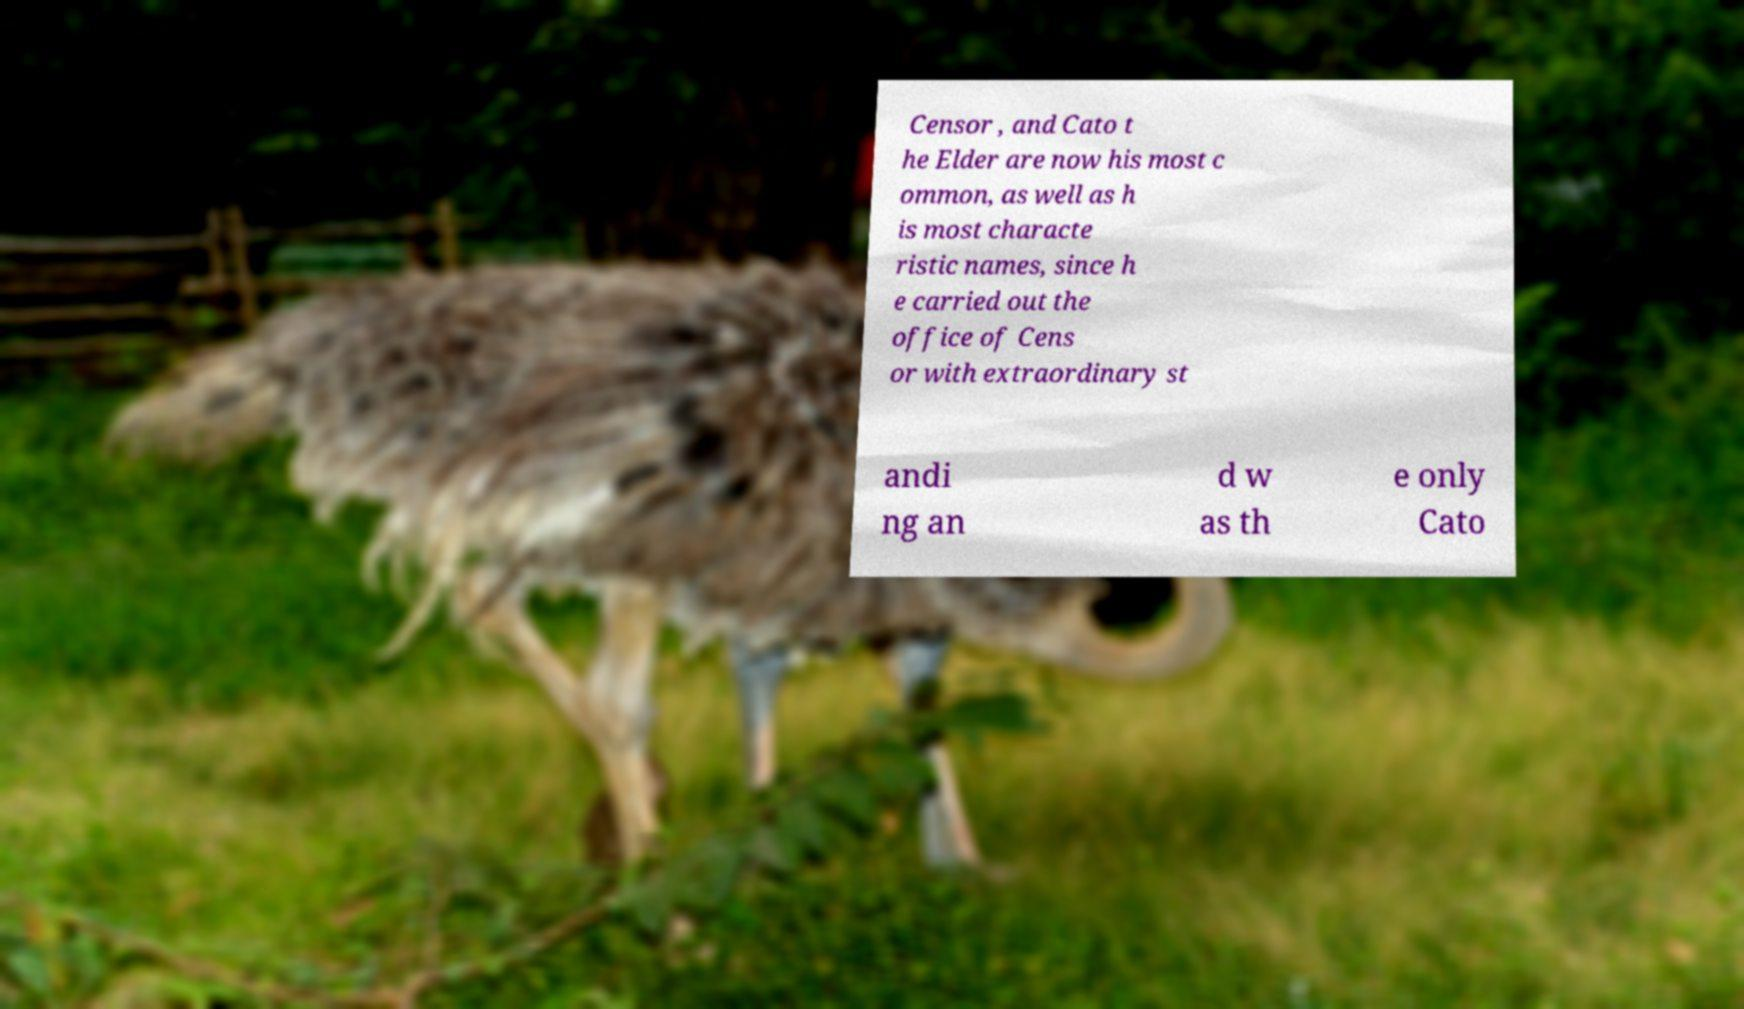Could you extract and type out the text from this image? Censor , and Cato t he Elder are now his most c ommon, as well as h is most characte ristic names, since h e carried out the office of Cens or with extraordinary st andi ng an d w as th e only Cato 